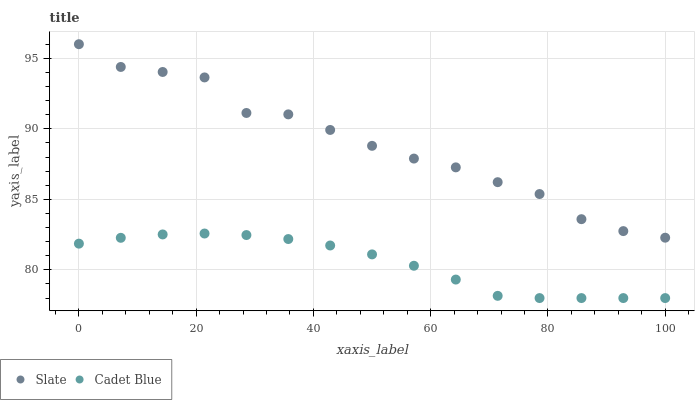Does Cadet Blue have the minimum area under the curve?
Answer yes or no. Yes. Does Slate have the maximum area under the curve?
Answer yes or no. Yes. Does Cadet Blue have the maximum area under the curve?
Answer yes or no. No. Is Cadet Blue the smoothest?
Answer yes or no. Yes. Is Slate the roughest?
Answer yes or no. Yes. Is Cadet Blue the roughest?
Answer yes or no. No. Does Cadet Blue have the lowest value?
Answer yes or no. Yes. Does Slate have the highest value?
Answer yes or no. Yes. Does Cadet Blue have the highest value?
Answer yes or no. No. Is Cadet Blue less than Slate?
Answer yes or no. Yes. Is Slate greater than Cadet Blue?
Answer yes or no. Yes. Does Cadet Blue intersect Slate?
Answer yes or no. No. 